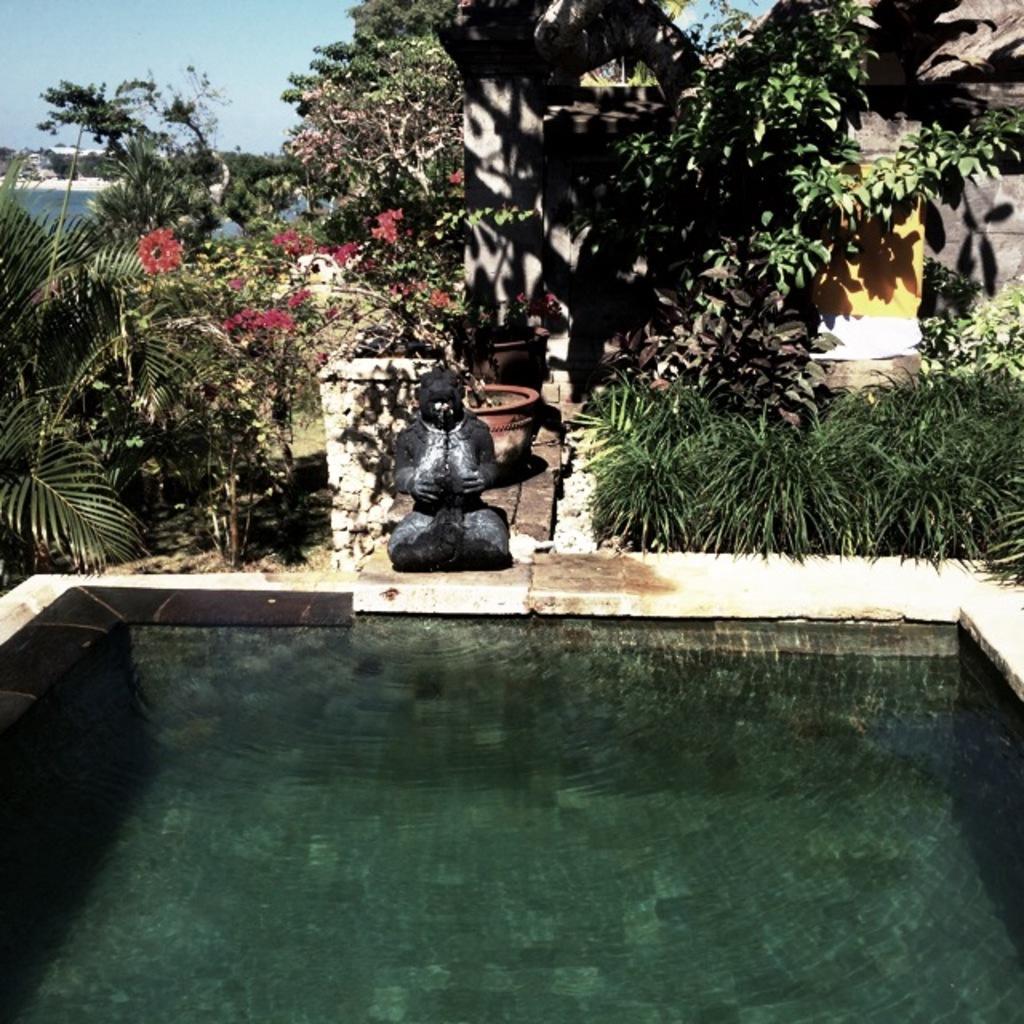Can you describe this image briefly? In this image there is some water at the bottom. In the middle it looks like a sculpture. Behind it there are flower pots. On the left side there are plants on the ground. At the top there is the sky. On the right side top it looks like a house. In the background there is water. 